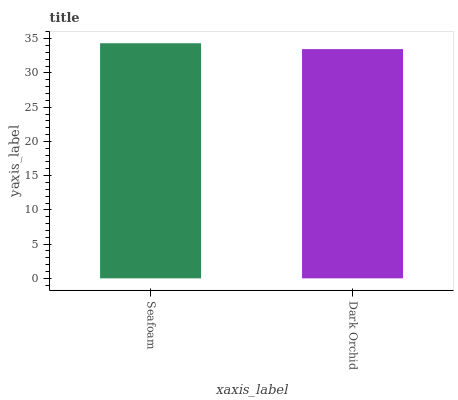Is Dark Orchid the minimum?
Answer yes or no. Yes. Is Seafoam the maximum?
Answer yes or no. Yes. Is Dark Orchid the maximum?
Answer yes or no. No. Is Seafoam greater than Dark Orchid?
Answer yes or no. Yes. Is Dark Orchid less than Seafoam?
Answer yes or no. Yes. Is Dark Orchid greater than Seafoam?
Answer yes or no. No. Is Seafoam less than Dark Orchid?
Answer yes or no. No. Is Seafoam the high median?
Answer yes or no. Yes. Is Dark Orchid the low median?
Answer yes or no. Yes. Is Dark Orchid the high median?
Answer yes or no. No. Is Seafoam the low median?
Answer yes or no. No. 